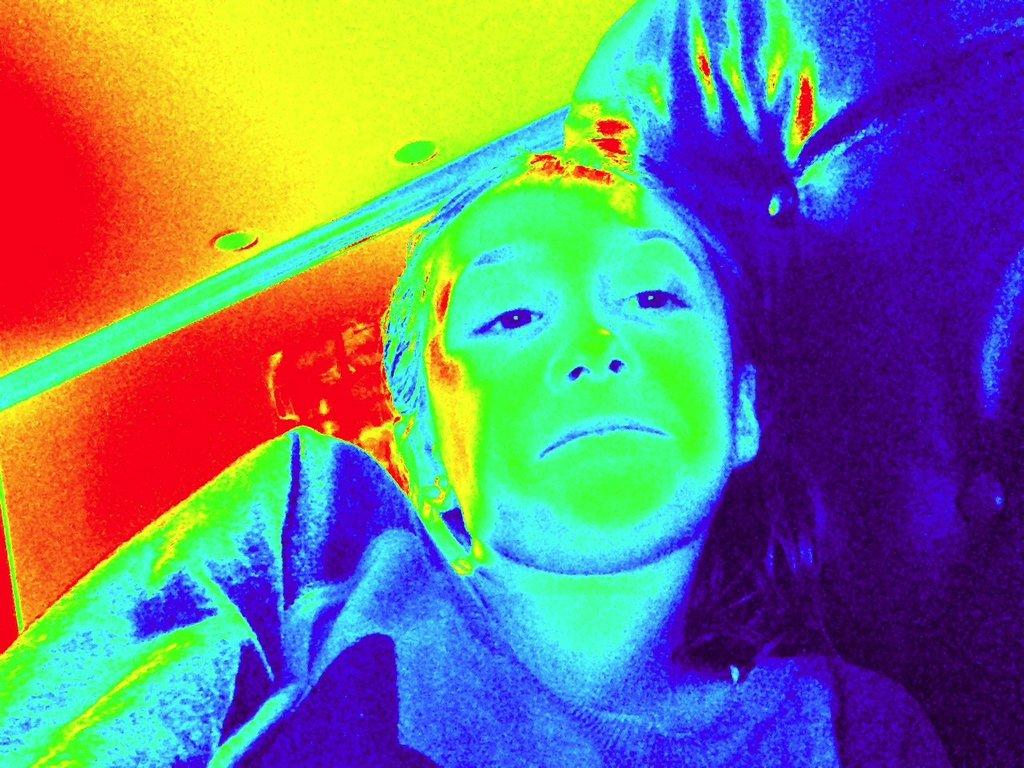Who or what is at the bottom of the image? There is a person at the bottom of the image. What can be seen in the background of the image? The background of the image is colorful. How many cacti are visible in the image? There are no cacti present in the image. What type of frog can be seen hopping in the image? There is no frog present in the image. 